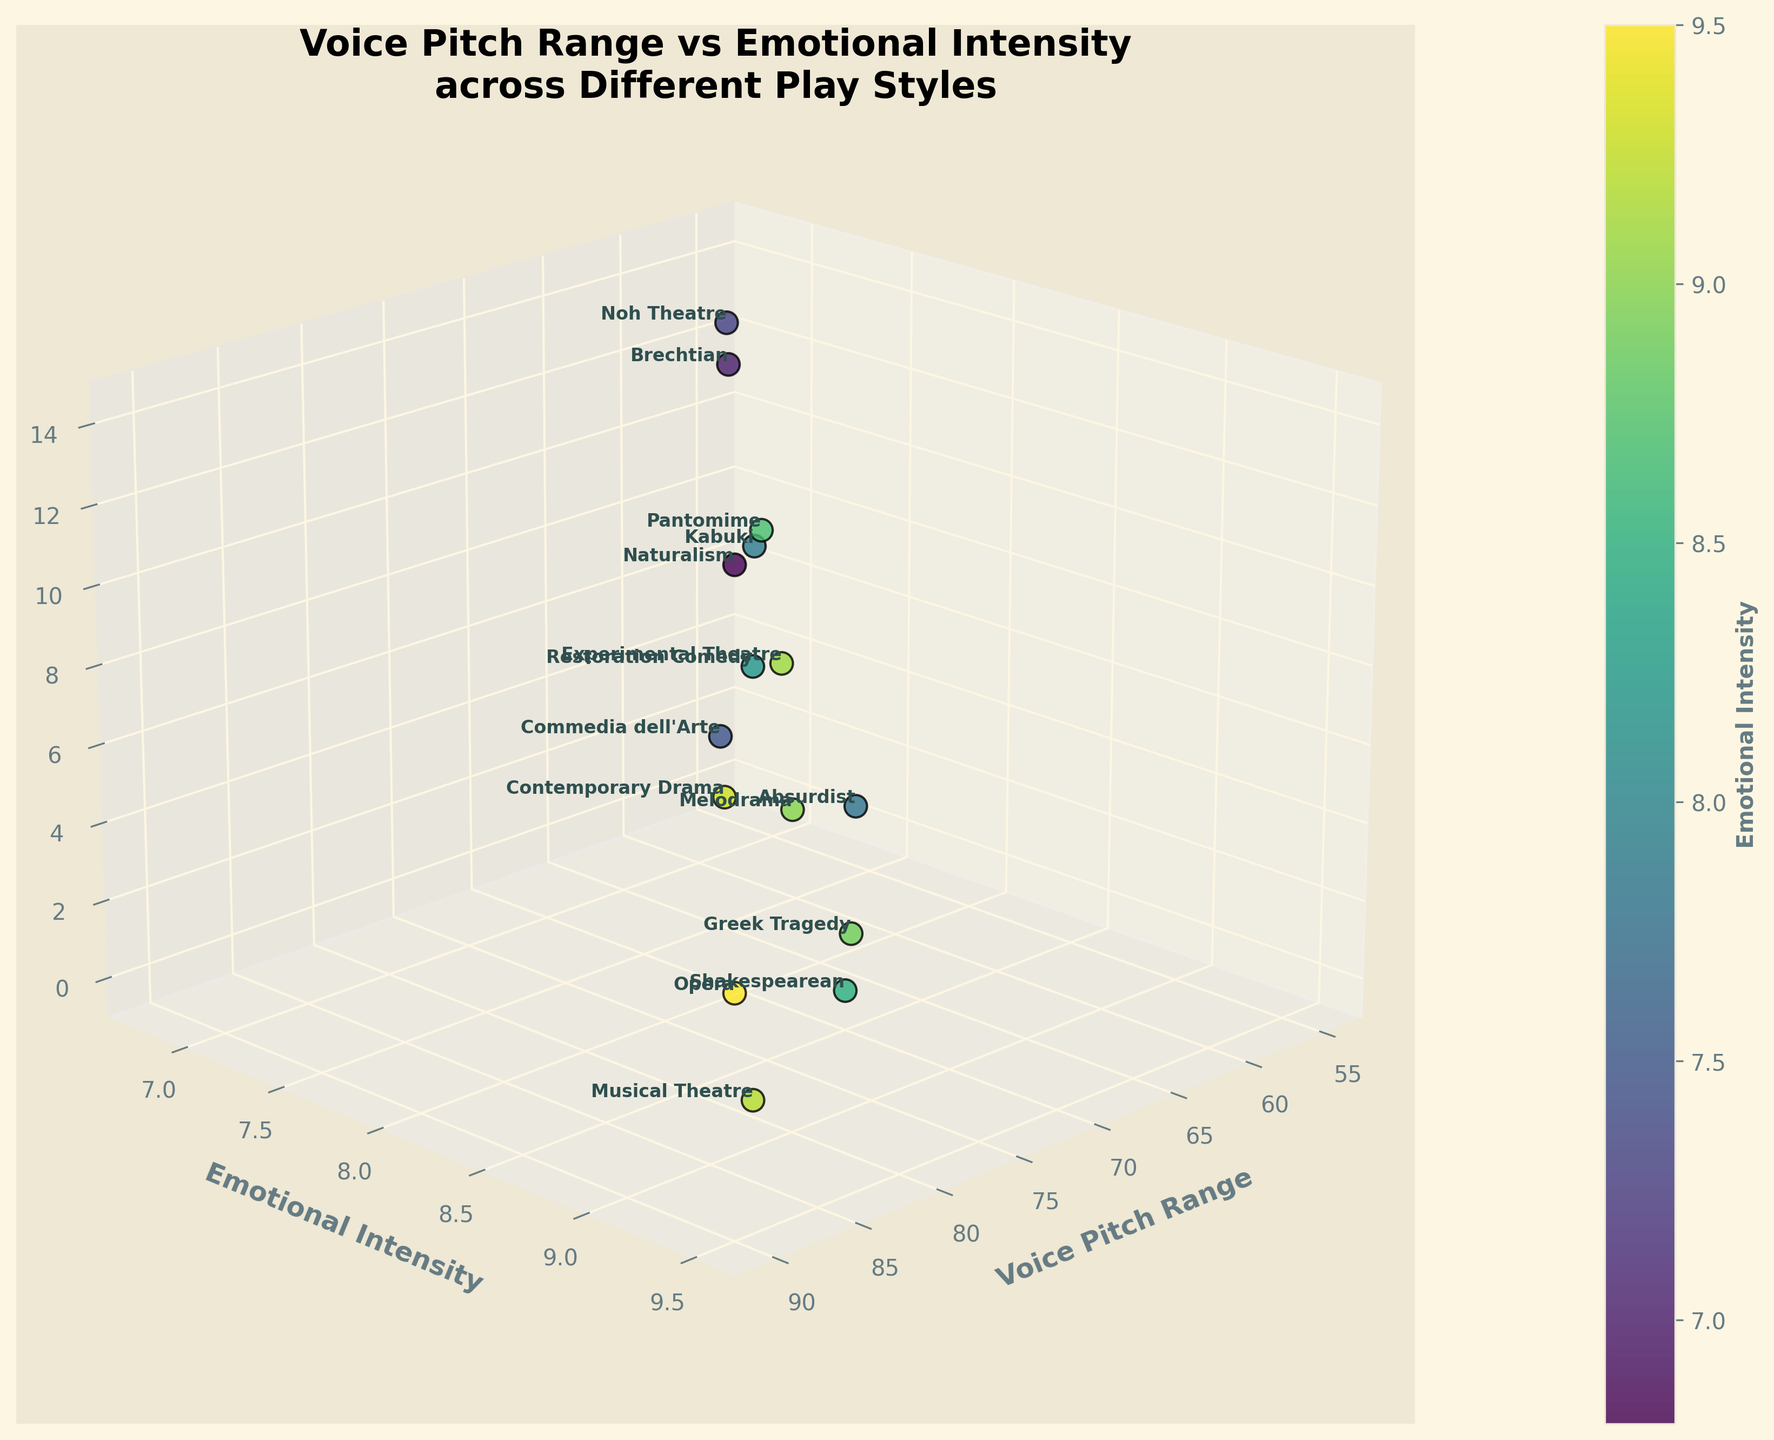What's the title of the plot? The title of the plot is usually located at the top. From the rendered figure, we can read the main heading which is centrally aligned.
Answer: Voice Pitch Range vs Emotional Intensity across Different Play Styles How many different play styles are represented in the plot? By counting the unique text labels (play styles) annotated in the plot, we can determine the number of different play styles shown.
Answer: 15 Which play style has the highest emotional intensity? Observe the y-axis labeled 'Emotional Intensity' and locate the highest data point. Read the associated play style label.
Answer: Opera Which play style has the lowest voice pitch range? Examine the x-axis labeled 'Voice Pitch Range' and identify the smallest value. Read the corresponding play style label.
Answer: Brechtian What is the voice pitch range of Shakespearean plays? Find the text label for 'Shakespearean' and check its position along the x-axis labeled 'Voice Pitch Range'.
Answer: 70 What's the average emotional intensity for all the play styles? Sum all the emotional intensity values and divide by the number of play styles (15). Calculation: (8.5 + 9.2 + 7.8 + 8.9 + 7.5 + 9.5 + 6.8 + 9.0 + 8.2 + 9.3 + 7.9 + 9.1 + 7.0 + 8.7 + 7.3) / 15.
Answer: 8.3 What is the difference in voice pitch range between Opera and Brechtian plays? Identify the voice pitch ranges for Opera and Brechtian from the x-axis, then compute the difference (90 - 58).
Answer: 32 Which play style is positioned at the highest z-axis value? The z-axis represents different play styles sequentially; locate the highest z-value and read its corresponding play style.
Answer: Noh Theatre Is there a general trend between voice pitch range and emotional intensity? Observe the scatter plot and determine if higher voice pitch ranges tend to correspond with higher emotional intensities or any other correlation trend.
Answer: Positive correlation What's the range of emotional intensities in the plot? Identify the maximum and minimum values on the y-axis labeled 'Emotional Intensity' and compute the difference (9.5 - 6.8).
Answer: 2.7 